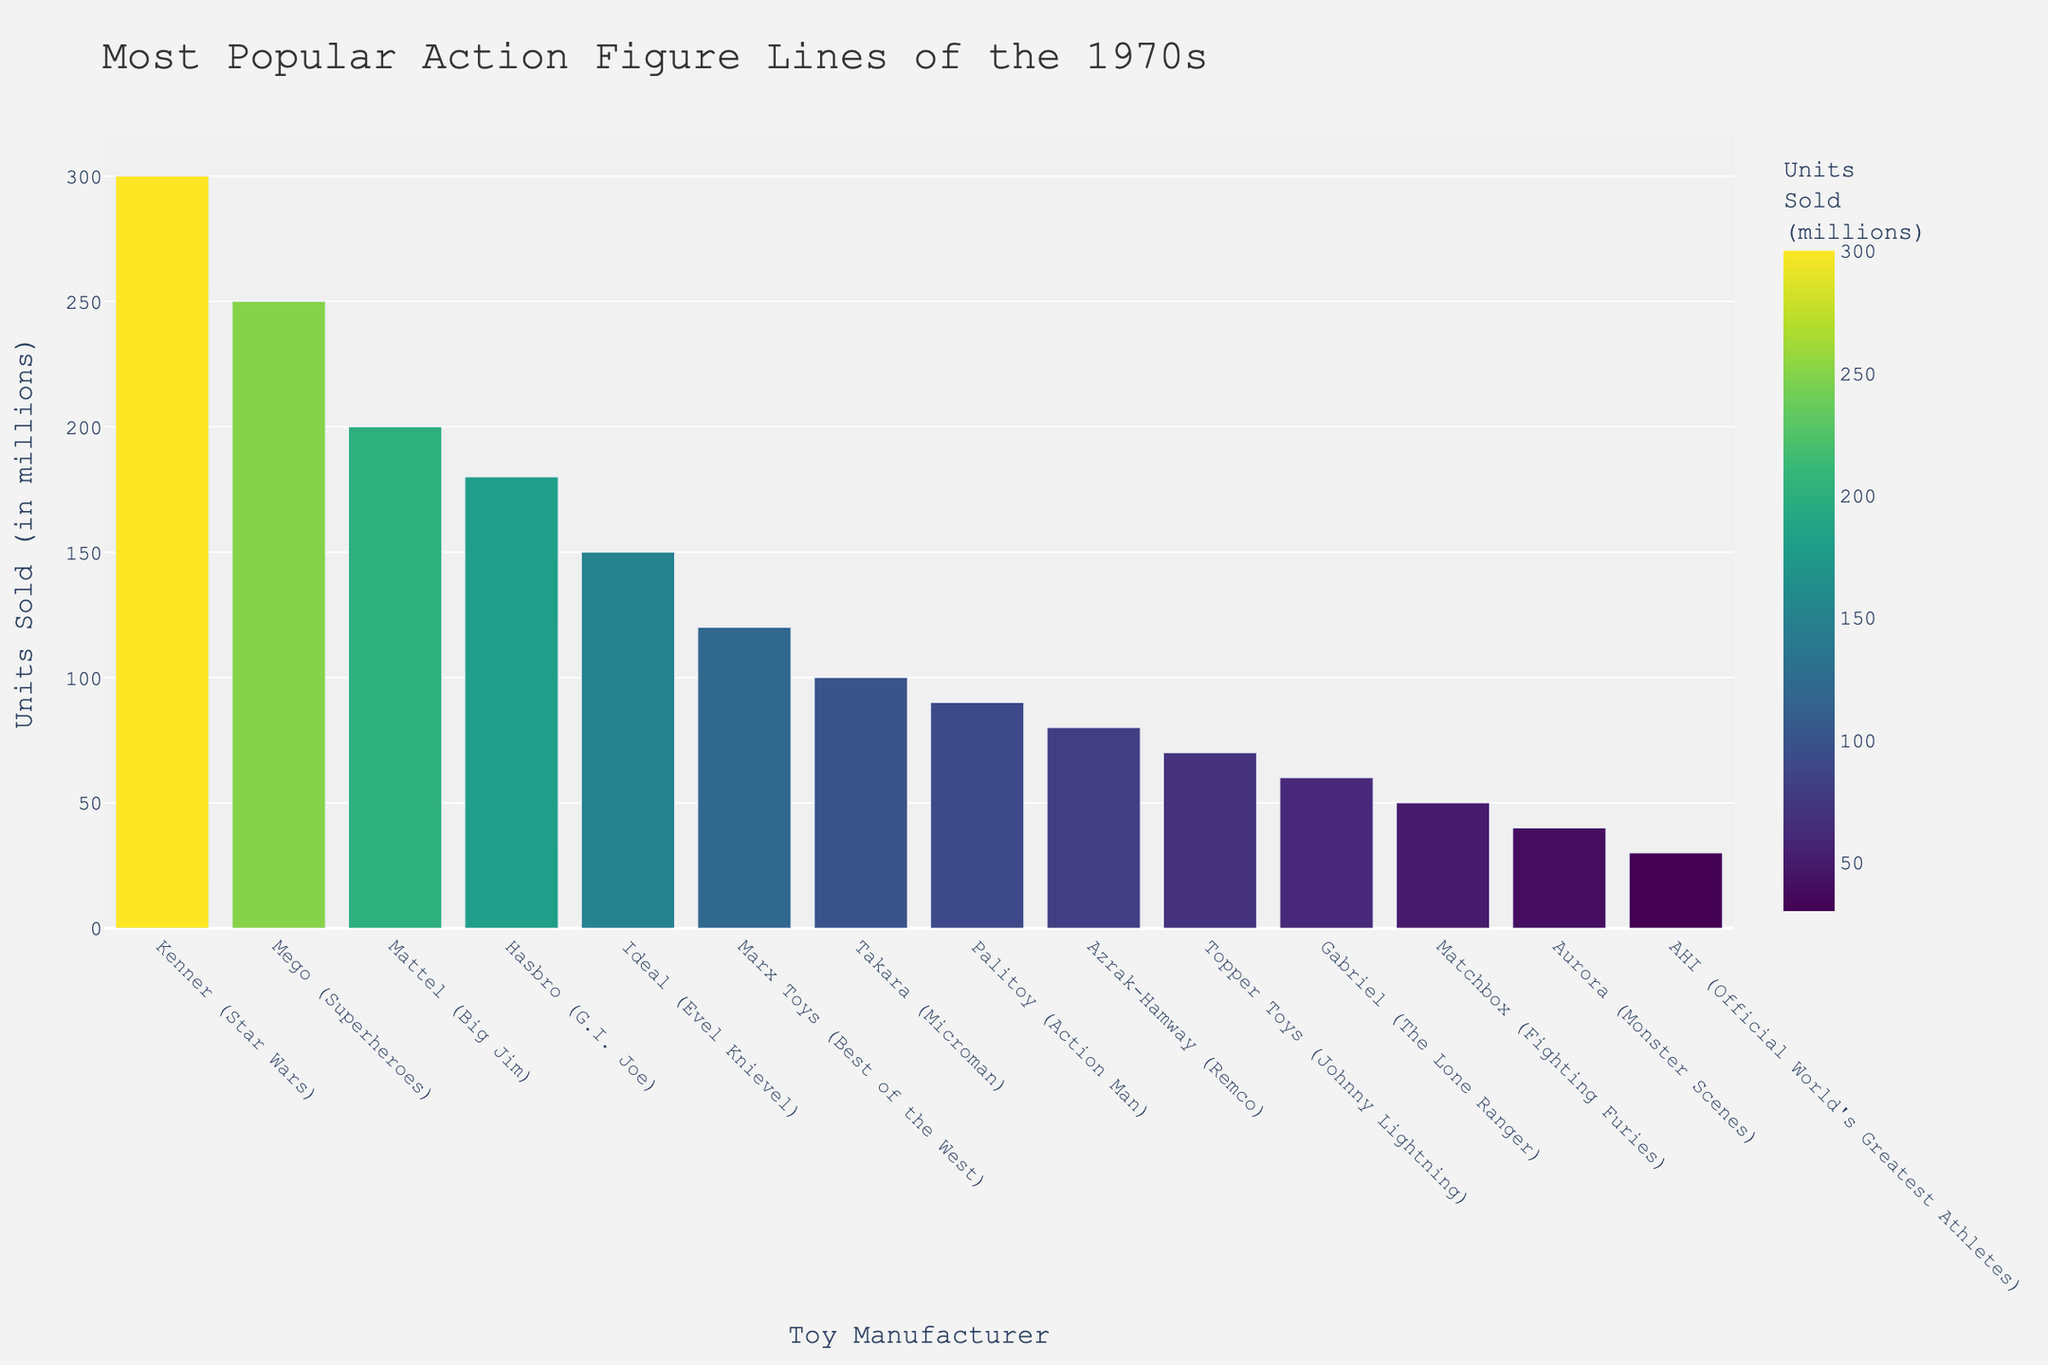Who is the manufacturer with the highest units sold? Look for the bar with the greatest height, which represents the most units sold. In this chart, it is Kenner (Star Wars) with 300 million units.
Answer: Kenner (Star Wars) Which manufacturer sold more action figures, Mattel (Big Jim) or Hasbro (G.I. Joe)? Compare the bars for Mattel (Big Jim) and Hasbro (G.I. Joe). Mattel (Big Jim) has 200 million units sold, while Hasbro (G.I. Joe) has 180 million units sold.
Answer: Mattel (Big Jim) What is the total units sold by manufacturers Kenner (Star Wars) and Mego (Superheroes)? Add the units sold by both manufacturers: Kenner (Star Wars) with 300 million and Mego (Superheroes) with 250 million. So, 300 + 250 = 550 million.
Answer: 550 million Which manufacturer has the second lowest units sold? Identify the second shortest bar in the chart. The shortest is AHI (Official World's Greatest Athletes) with 30 million, and the next shortest is Aurora (Monster Scenes) with 40 million.
Answer: Aurora (Monster Scenes) What is the difference in units sold between Ideal (Evel Knievel) and Marx Toys (Best of the West)? Calculate the difference between the units sold by Ideal (Evel Knievel) with 150 million and Marx Toys (Best of the West) with 120 million. So, 150 - 120 = 30 million.
Answer: 30 million How many manufacturers sold more than 100 million units? Count the number of bars that represent units sold greater than 100 million. These are Kenner (Star Wars), Mego (Superheroes), Mattel (Big Jim), Hasbro (G.I. Joe), and Ideal (Evel Knievel).
Answer: 5 What percentage of the total units sold were sold by Kenner (Star Wars)? First, sum up all the units sold by all manufacturers. The total is 300 + 250 + 200 + 180 + 150 + 120 + 100 + 90 + 80 + 70 + 60 + 50 + 40 + 30 = 1720 million. Then, calculate the percentage: (300/1720) * 100 = 17.44%.
Answer: 17.44% Which manufacturers sold exactly 80 million units? Look for the bar representing 80 million units sold and identify the corresponding manufacturer. The chart shows Azrak-Hamway (Remco) with 80 million units.
Answer: Azrak-Hamway (Remco) If Palitoy (Action Man) and Topper Toys (Johnny Lightning) combined their units sold, would their total be greater than Mattel (Big Jim)? Add the units sold by Palitoy (Action Man) with 90 million and Topper Toys (Johnny Lightning) with 70 million. Their combined total is 90 + 70 = 160 million. Compare this to Mattel (Big Jim) which has 200 million units sold.
Answer: No Which manufacturer has a bar that appears in a green shade in the color scale? Look at the color scale to identify manufacturers that fall into the range where green appears. In the Viridis color scale, the middle range often appears green. Manufacturers close to the middle in terms of units sold could be Hasbro (G.I. Joe) with 180 million or Ideal (Evel Knievel) with 150 million.
Answer: Hasbro (G.I. Joe) 